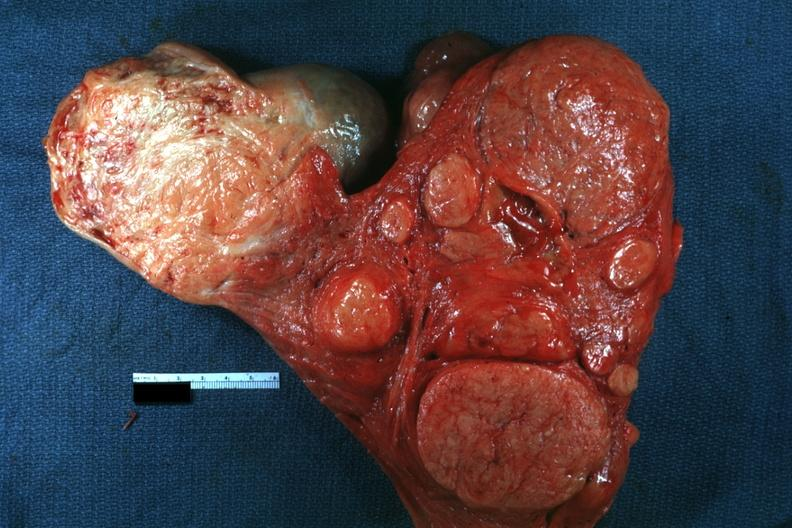s leiomyomas present?
Answer the question using a single word or phrase. Yes 